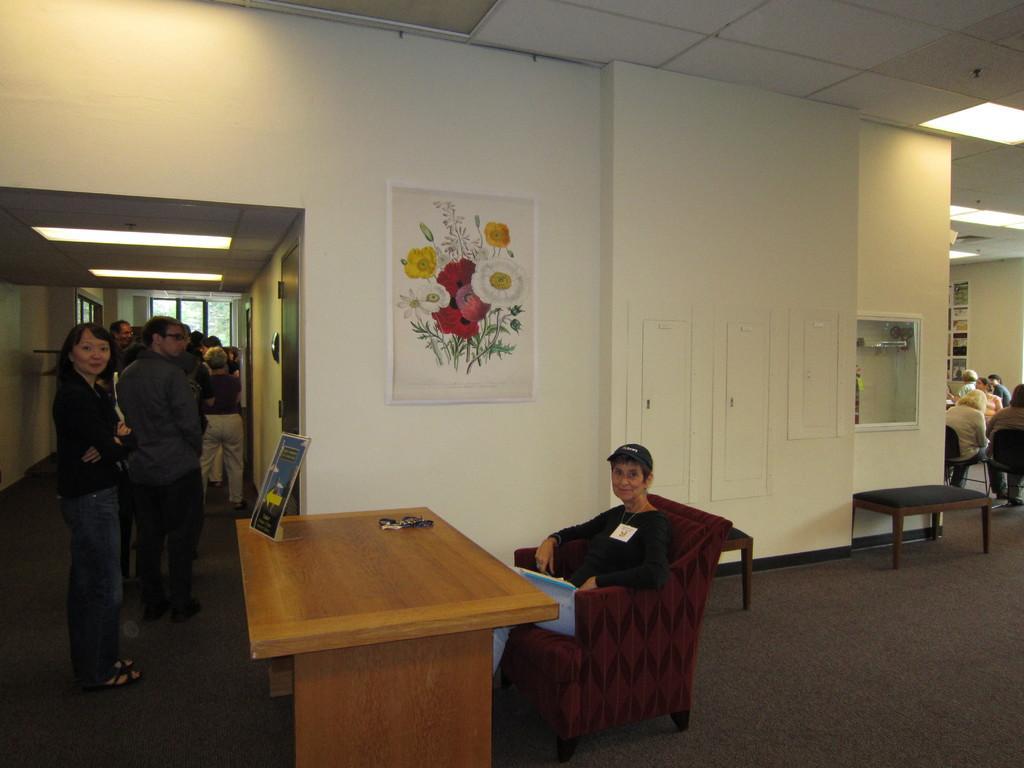How would you summarize this image in a sentence or two? This picture shows a group of people standing and a woman seated on the chair and we see a table and a photo frame on the wall 